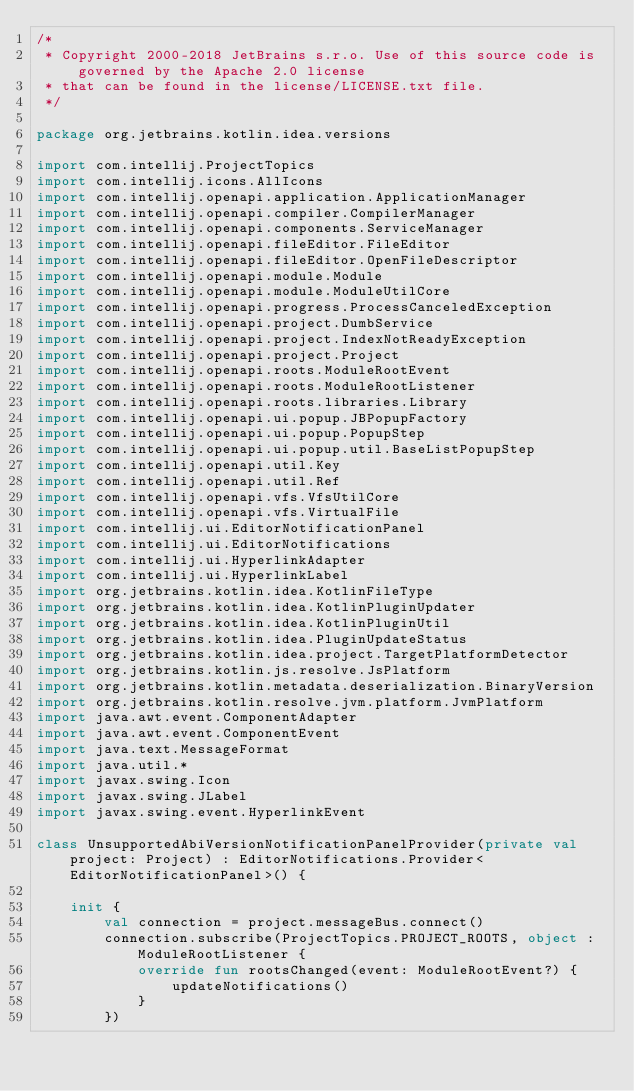Convert code to text. <code><loc_0><loc_0><loc_500><loc_500><_Kotlin_>/*
 * Copyright 2000-2018 JetBrains s.r.o. Use of this source code is governed by the Apache 2.0 license
 * that can be found in the license/LICENSE.txt file.
 */

package org.jetbrains.kotlin.idea.versions

import com.intellij.ProjectTopics
import com.intellij.icons.AllIcons
import com.intellij.openapi.application.ApplicationManager
import com.intellij.openapi.compiler.CompilerManager
import com.intellij.openapi.components.ServiceManager
import com.intellij.openapi.fileEditor.FileEditor
import com.intellij.openapi.fileEditor.OpenFileDescriptor
import com.intellij.openapi.module.Module
import com.intellij.openapi.module.ModuleUtilCore
import com.intellij.openapi.progress.ProcessCanceledException
import com.intellij.openapi.project.DumbService
import com.intellij.openapi.project.IndexNotReadyException
import com.intellij.openapi.project.Project
import com.intellij.openapi.roots.ModuleRootEvent
import com.intellij.openapi.roots.ModuleRootListener
import com.intellij.openapi.roots.libraries.Library
import com.intellij.openapi.ui.popup.JBPopupFactory
import com.intellij.openapi.ui.popup.PopupStep
import com.intellij.openapi.ui.popup.util.BaseListPopupStep
import com.intellij.openapi.util.Key
import com.intellij.openapi.util.Ref
import com.intellij.openapi.vfs.VfsUtilCore
import com.intellij.openapi.vfs.VirtualFile
import com.intellij.ui.EditorNotificationPanel
import com.intellij.ui.EditorNotifications
import com.intellij.ui.HyperlinkAdapter
import com.intellij.ui.HyperlinkLabel
import org.jetbrains.kotlin.idea.KotlinFileType
import org.jetbrains.kotlin.idea.KotlinPluginUpdater
import org.jetbrains.kotlin.idea.KotlinPluginUtil
import org.jetbrains.kotlin.idea.PluginUpdateStatus
import org.jetbrains.kotlin.idea.project.TargetPlatformDetector
import org.jetbrains.kotlin.js.resolve.JsPlatform
import org.jetbrains.kotlin.metadata.deserialization.BinaryVersion
import org.jetbrains.kotlin.resolve.jvm.platform.JvmPlatform
import java.awt.event.ComponentAdapter
import java.awt.event.ComponentEvent
import java.text.MessageFormat
import java.util.*
import javax.swing.Icon
import javax.swing.JLabel
import javax.swing.event.HyperlinkEvent

class UnsupportedAbiVersionNotificationPanelProvider(private val project: Project) : EditorNotifications.Provider<EditorNotificationPanel>() {

    init {
        val connection = project.messageBus.connect()
        connection.subscribe(ProjectTopics.PROJECT_ROOTS, object : ModuleRootListener {
            override fun rootsChanged(event: ModuleRootEvent?) {
                updateNotifications()
            }
        })</code> 